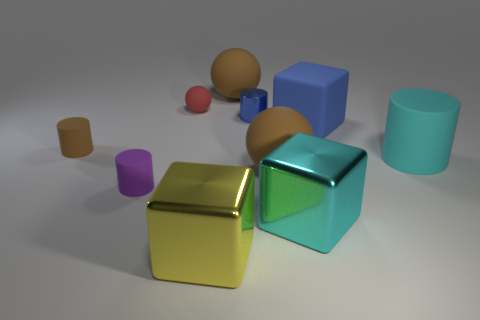Are there the same number of purple rubber things in front of the tiny purple rubber cylinder and cyan cylinders?
Give a very brief answer. No. What number of rubber cylinders are behind the small purple matte thing and on the left side of the tiny red rubber thing?
Ensure brevity in your answer.  1. What is the size of the cube that is the same material as the tiny purple thing?
Your answer should be very brief. Large. How many blue matte things are the same shape as the small brown object?
Provide a succinct answer. 0. Is the number of small rubber things that are in front of the red thing greater than the number of red objects?
Keep it short and to the point. Yes. There is a big thing that is both in front of the cyan rubber cylinder and behind the big cyan metallic thing; what is its shape?
Make the answer very short. Sphere. Does the yellow metal cube have the same size as the blue cylinder?
Give a very brief answer. No. There is a small blue thing; what number of blocks are left of it?
Your answer should be compact. 1. Is the number of large blue rubber things on the left side of the brown cylinder the same as the number of matte objects that are in front of the small blue shiny thing?
Give a very brief answer. No. There is a large brown matte object behind the tiny red object; is its shape the same as the large yellow shiny thing?
Your answer should be compact. No. 